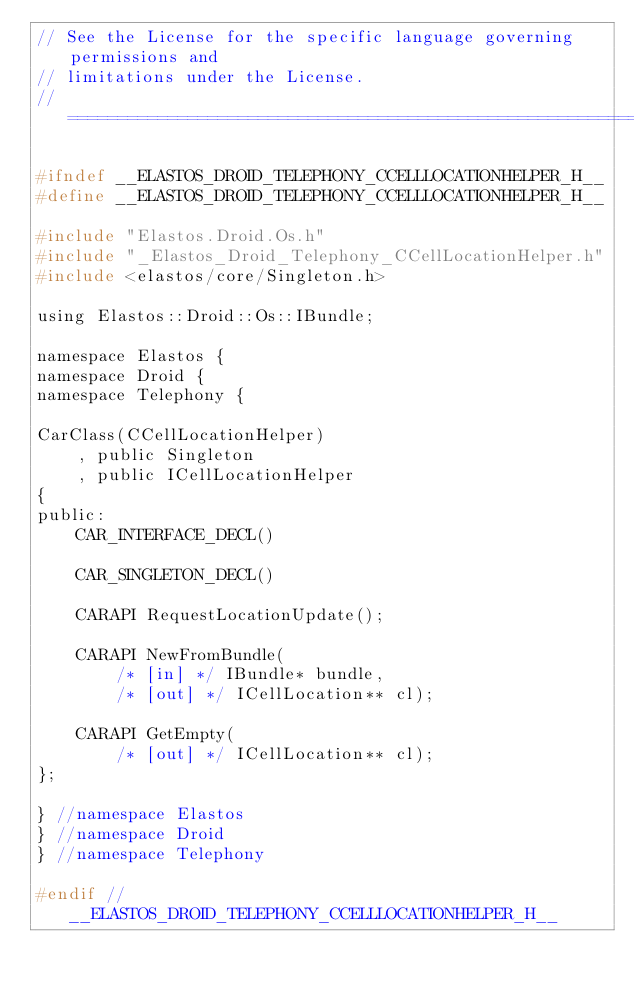<code> <loc_0><loc_0><loc_500><loc_500><_C_>// See the License for the specific language governing permissions and
// limitations under the License.
//=========================================================================

#ifndef __ELASTOS_DROID_TELEPHONY_CCELLLOCATIONHELPER_H__
#define __ELASTOS_DROID_TELEPHONY_CCELLLOCATIONHELPER_H__

#include "Elastos.Droid.Os.h"
#include "_Elastos_Droid_Telephony_CCellLocationHelper.h"
#include <elastos/core/Singleton.h>

using Elastos::Droid::Os::IBundle;

namespace Elastos {
namespace Droid {
namespace Telephony {

CarClass(CCellLocationHelper)
    , public Singleton
    , public ICellLocationHelper
{
public:
    CAR_INTERFACE_DECL()

    CAR_SINGLETON_DECL()

    CARAPI RequestLocationUpdate();

    CARAPI NewFromBundle(
        /* [in] */ IBundle* bundle,
        /* [out] */ ICellLocation** cl);

    CARAPI GetEmpty(
        /* [out] */ ICellLocation** cl);
};

} //namespace Elastos
} //namespace Droid
} //namespace Telephony

#endif // __ELASTOS_DROID_TELEPHONY_CCELLLOCATIONHELPER_H__
</code> 